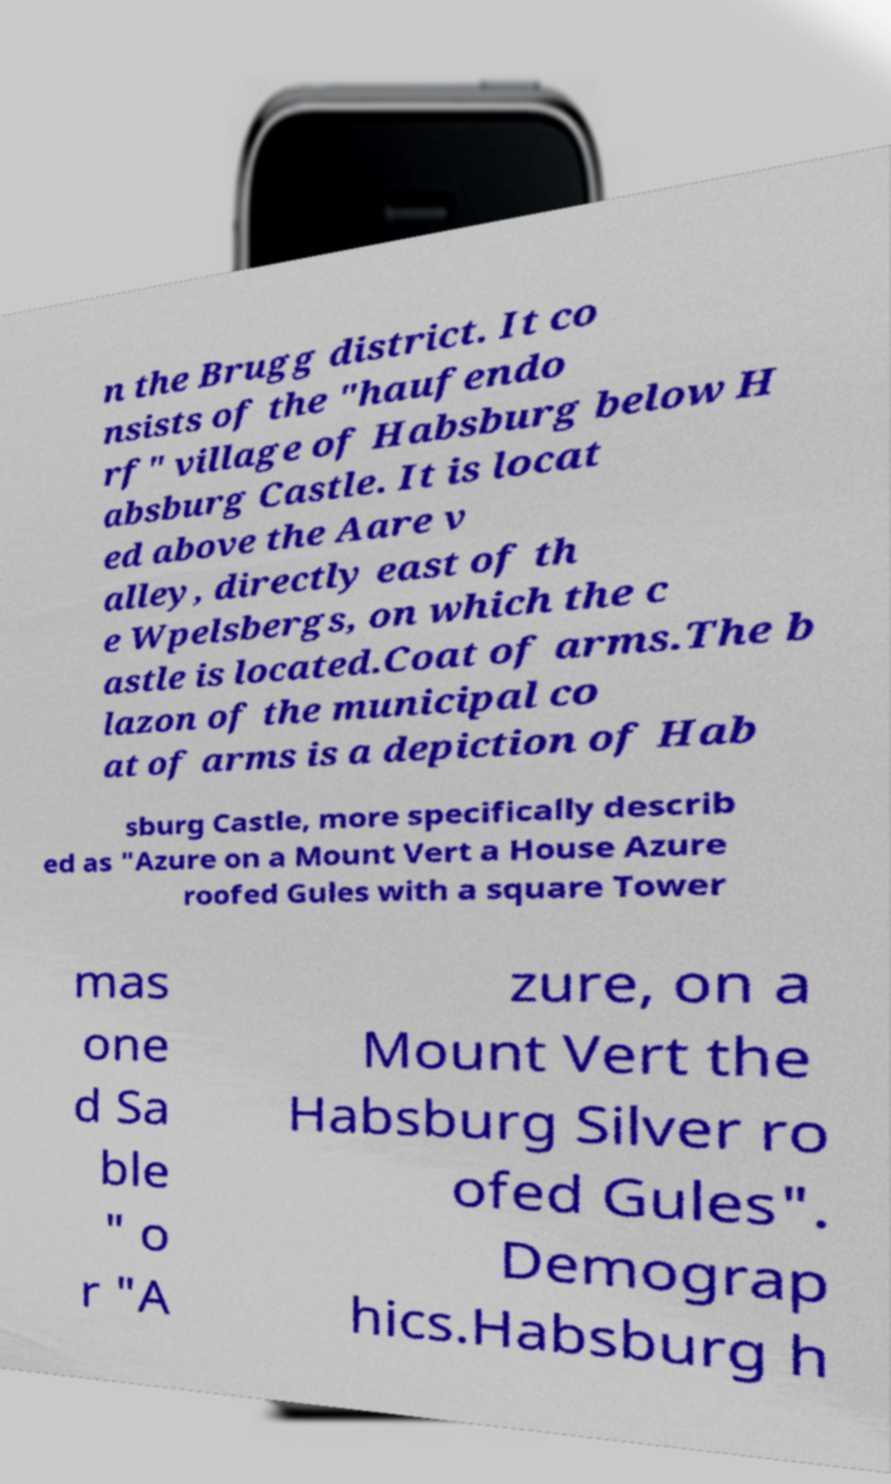Could you assist in decoding the text presented in this image and type it out clearly? n the Brugg district. It co nsists of the "haufendo rf" village of Habsburg below H absburg Castle. It is locat ed above the Aare v alley, directly east of th e Wpelsbergs, on which the c astle is located.Coat of arms.The b lazon of the municipal co at of arms is a depiction of Hab sburg Castle, more specifically describ ed as "Azure on a Mount Vert a House Azure roofed Gules with a square Tower mas one d Sa ble " o r "A zure, on a Mount Vert the Habsburg Silver ro ofed Gules". Demograp hics.Habsburg h 